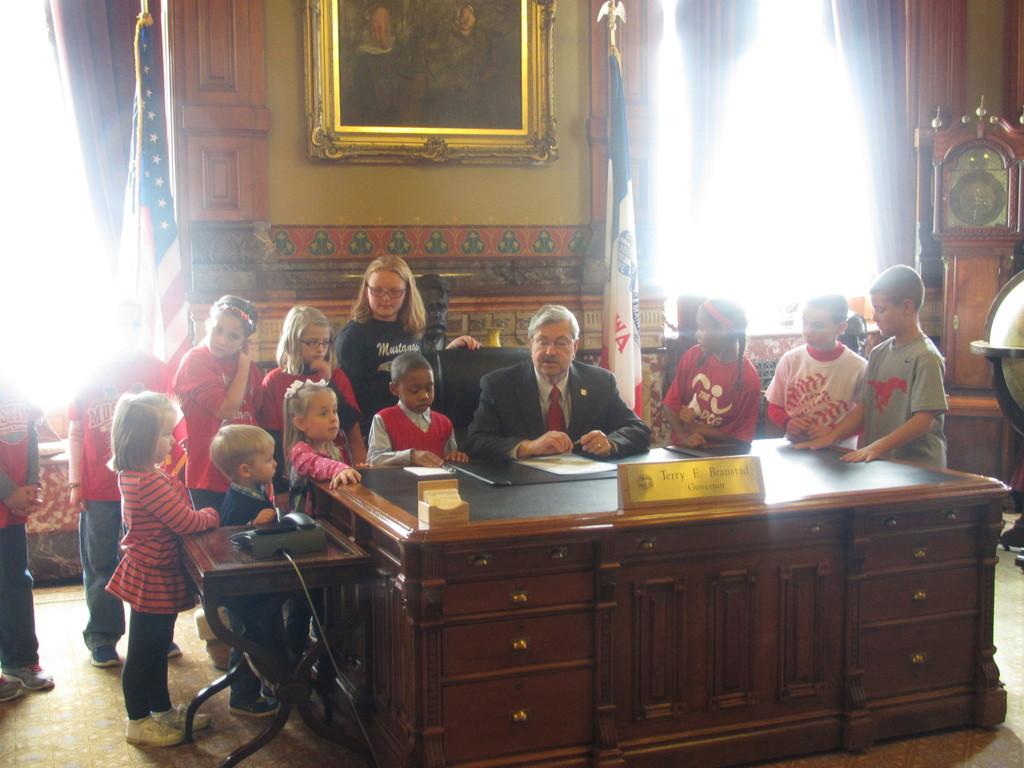What is the man in the image doing? The man is sitting on a chair in the image. Who else is present in the image besides the man? There are children in the image. What can be seen in the background of the image? There are two flags and a frame on the wall in the background of the image. Can you identify any objects that indicate the time or help with timekeeping in the image? Yes, there is a clock visible in the image. What type of snow can be seen falling in the image? There is no snow present in the image; it is an indoor setting with no indication of snow or cold weather. 